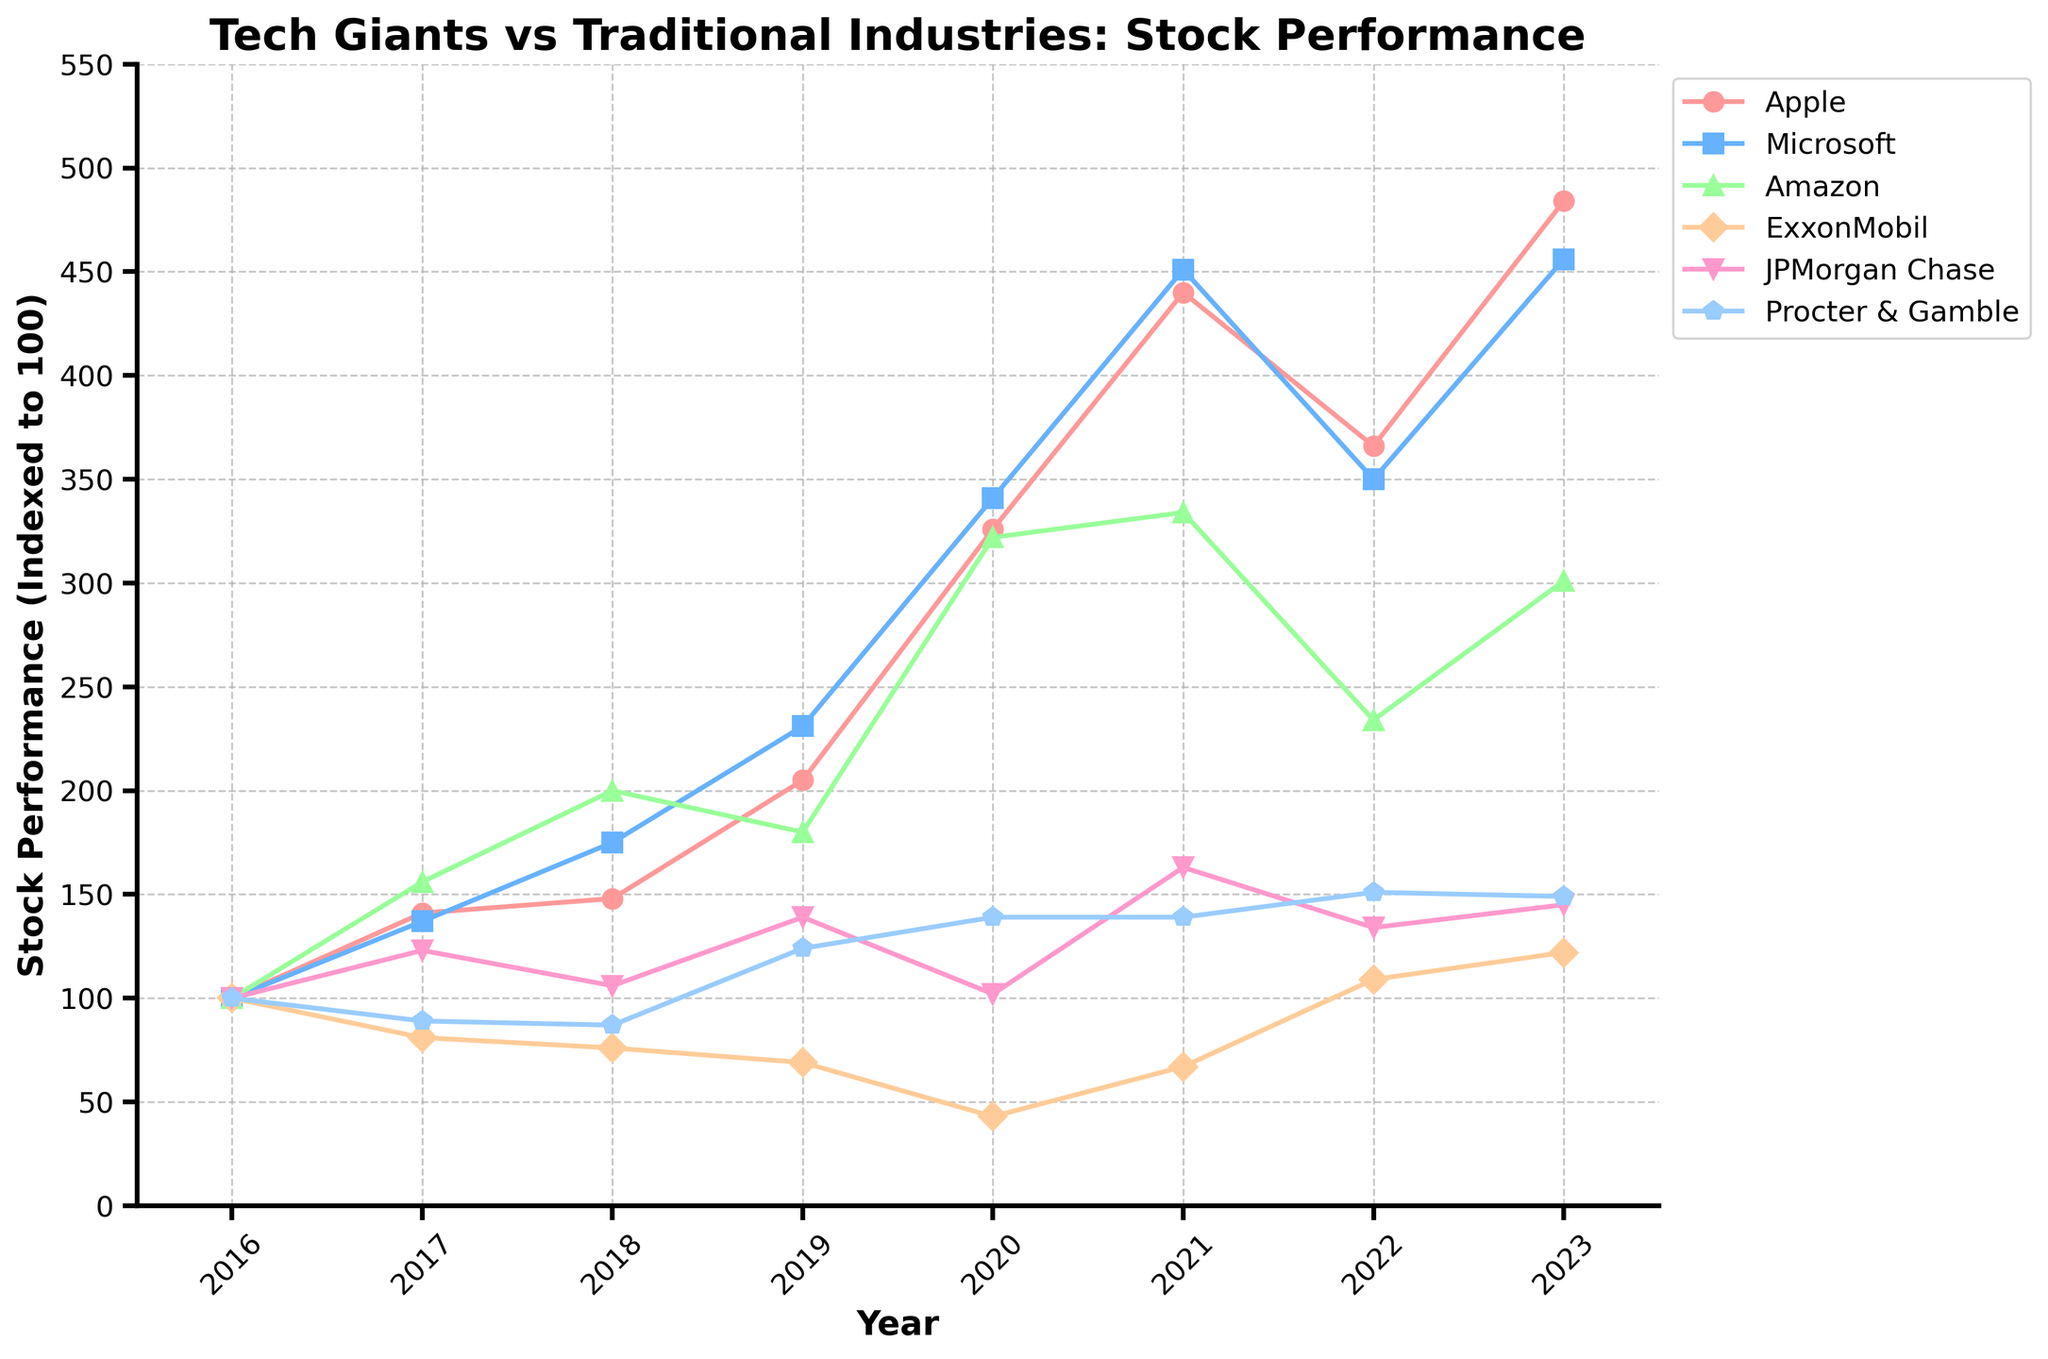What year did Apple have its peak stock performance, and what was the value? Looking at Apple's line on the plot, the peak occurs at the highest point along the "Year" axis, which is in 2023. The value associated with this peak is the corresponding vertical position along the "Stock Performance" axis, which is 484.
Answer: 2023, 484 Which company had the highest stock performance in 2021, and what was the value? By comparing the lines for all companies, the plot shows that Microsoft reached its highest stock performance in 2021. The value is seen by finding the corresponding vertical position on the "Stock Performance" axis, which is 451.
Answer: Microsoft, 451 Which year did ExxonMobil have the lowest stock performance, and what was the value? Looking at ExxonMobil's line, the lowest point is in 2020. The value for this point is read from the "Stock Performance" axis, which is 43.
Answer: 2020, 43 Compare Apple and Amazon in 2023. Which has the higher stock performance, and by how much? From the plot, in 2023, Apple's stock performance is 484 and Amazon's is 301. The difference is calculated as 484 - 301 = 183.
Answer: Apple, 183 Did any company have a stock performance under 50 in 2020? If so, which? Observing the plot for 2020, ExxonMobil's line reached a value under 50, specifically at 43.
Answer: ExxonMobil Between 2019 and 2021, which company experienced the greatest increase in stock performance, and what was the value of that increase? From 2019 to 2021, Apple increased from 205 to 440, which is an increase of 235. Calculating similar differences for Microsoft, Amazon, ExxonMobil, JPMorgan Chase, and Procter & Gamble, none surpasses 235.
Answer: Apple, 235 Which two companies had the closest stock performance in 2022, and what were their values? In 2022, Microsoft's and Apple's stock performances were closest, with Microsoft at 350 and Apple at 366, a difference of 16.
Answer: Microsoft (350) and Apple (366) Which company had the most stable stock performance from 2016 to 2023, and why do you conclude this? Procter & Gamble's stock performance shows the least fluctuation as seen by the relatively flat line compared to other companies.
Answer: Procter & Gamble By how much did JPMorgan Chase’s stock performance change from 2018 to 2019? JPMorgan Chase’s stock performance went from 106 in 2018 to 139 in 2019. The change is calculated as 139 - 106 = 33.
Answer: 33 